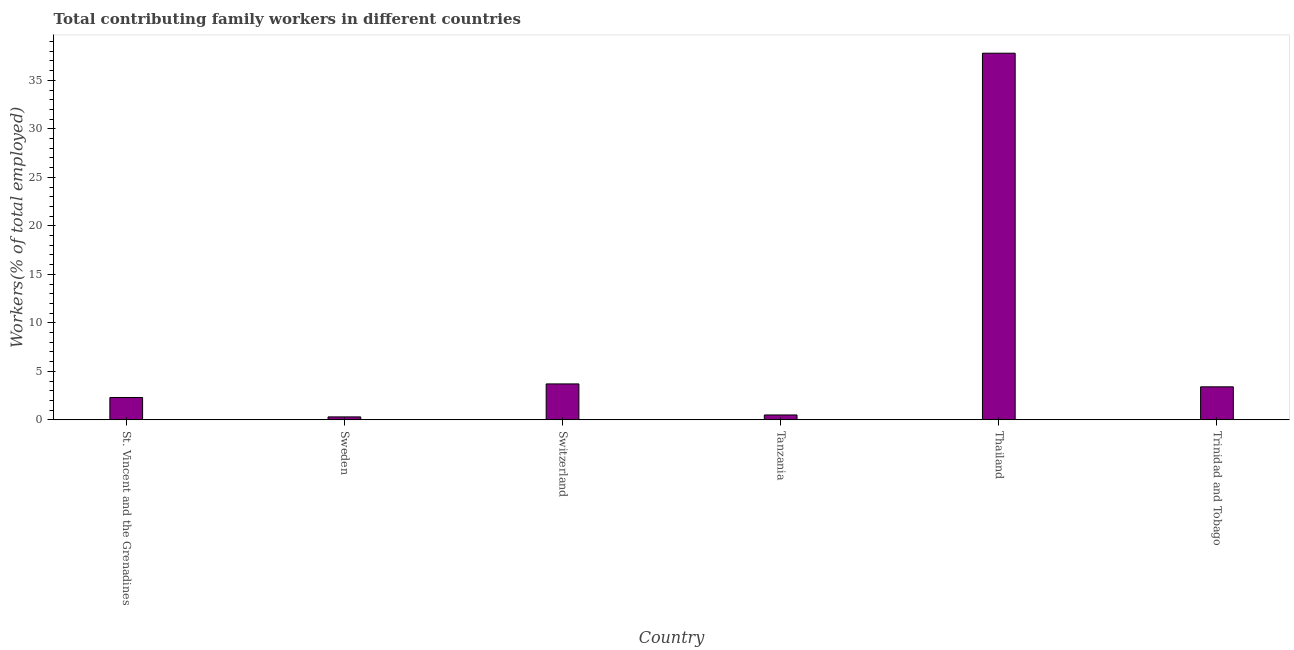Does the graph contain any zero values?
Provide a succinct answer. No. What is the title of the graph?
Give a very brief answer. Total contributing family workers in different countries. What is the label or title of the X-axis?
Make the answer very short. Country. What is the label or title of the Y-axis?
Provide a succinct answer. Workers(% of total employed). What is the contributing family workers in Trinidad and Tobago?
Provide a succinct answer. 3.4. Across all countries, what is the maximum contributing family workers?
Offer a very short reply. 37.8. Across all countries, what is the minimum contributing family workers?
Offer a terse response. 0.3. In which country was the contributing family workers maximum?
Offer a very short reply. Thailand. What is the sum of the contributing family workers?
Make the answer very short. 48. What is the difference between the contributing family workers in Sweden and Tanzania?
Make the answer very short. -0.2. What is the average contributing family workers per country?
Make the answer very short. 8. What is the median contributing family workers?
Make the answer very short. 2.85. What is the ratio of the contributing family workers in Sweden to that in Thailand?
Your answer should be compact. 0.01. Is the contributing family workers in St. Vincent and the Grenadines less than that in Trinidad and Tobago?
Your answer should be very brief. Yes. What is the difference between the highest and the second highest contributing family workers?
Your answer should be very brief. 34.1. What is the difference between the highest and the lowest contributing family workers?
Make the answer very short. 37.5. Are all the bars in the graph horizontal?
Provide a succinct answer. No. What is the difference between two consecutive major ticks on the Y-axis?
Your answer should be very brief. 5. What is the Workers(% of total employed) of St. Vincent and the Grenadines?
Provide a succinct answer. 2.3. What is the Workers(% of total employed) in Sweden?
Provide a succinct answer. 0.3. What is the Workers(% of total employed) in Switzerland?
Provide a short and direct response. 3.7. What is the Workers(% of total employed) in Tanzania?
Your answer should be compact. 0.5. What is the Workers(% of total employed) in Thailand?
Keep it short and to the point. 37.8. What is the Workers(% of total employed) of Trinidad and Tobago?
Your answer should be compact. 3.4. What is the difference between the Workers(% of total employed) in St. Vincent and the Grenadines and Sweden?
Ensure brevity in your answer.  2. What is the difference between the Workers(% of total employed) in St. Vincent and the Grenadines and Switzerland?
Make the answer very short. -1.4. What is the difference between the Workers(% of total employed) in St. Vincent and the Grenadines and Tanzania?
Your response must be concise. 1.8. What is the difference between the Workers(% of total employed) in St. Vincent and the Grenadines and Thailand?
Offer a very short reply. -35.5. What is the difference between the Workers(% of total employed) in St. Vincent and the Grenadines and Trinidad and Tobago?
Your answer should be very brief. -1.1. What is the difference between the Workers(% of total employed) in Sweden and Switzerland?
Keep it short and to the point. -3.4. What is the difference between the Workers(% of total employed) in Sweden and Tanzania?
Give a very brief answer. -0.2. What is the difference between the Workers(% of total employed) in Sweden and Thailand?
Offer a terse response. -37.5. What is the difference between the Workers(% of total employed) in Sweden and Trinidad and Tobago?
Give a very brief answer. -3.1. What is the difference between the Workers(% of total employed) in Switzerland and Tanzania?
Your response must be concise. 3.2. What is the difference between the Workers(% of total employed) in Switzerland and Thailand?
Provide a short and direct response. -34.1. What is the difference between the Workers(% of total employed) in Switzerland and Trinidad and Tobago?
Ensure brevity in your answer.  0.3. What is the difference between the Workers(% of total employed) in Tanzania and Thailand?
Provide a succinct answer. -37.3. What is the difference between the Workers(% of total employed) in Thailand and Trinidad and Tobago?
Your answer should be compact. 34.4. What is the ratio of the Workers(% of total employed) in St. Vincent and the Grenadines to that in Sweden?
Give a very brief answer. 7.67. What is the ratio of the Workers(% of total employed) in St. Vincent and the Grenadines to that in Switzerland?
Ensure brevity in your answer.  0.62. What is the ratio of the Workers(% of total employed) in St. Vincent and the Grenadines to that in Tanzania?
Keep it short and to the point. 4.6. What is the ratio of the Workers(% of total employed) in St. Vincent and the Grenadines to that in Thailand?
Your answer should be compact. 0.06. What is the ratio of the Workers(% of total employed) in St. Vincent and the Grenadines to that in Trinidad and Tobago?
Your answer should be very brief. 0.68. What is the ratio of the Workers(% of total employed) in Sweden to that in Switzerland?
Offer a very short reply. 0.08. What is the ratio of the Workers(% of total employed) in Sweden to that in Tanzania?
Ensure brevity in your answer.  0.6. What is the ratio of the Workers(% of total employed) in Sweden to that in Thailand?
Provide a short and direct response. 0.01. What is the ratio of the Workers(% of total employed) in Sweden to that in Trinidad and Tobago?
Your response must be concise. 0.09. What is the ratio of the Workers(% of total employed) in Switzerland to that in Thailand?
Your answer should be compact. 0.1. What is the ratio of the Workers(% of total employed) in Switzerland to that in Trinidad and Tobago?
Your answer should be very brief. 1.09. What is the ratio of the Workers(% of total employed) in Tanzania to that in Thailand?
Make the answer very short. 0.01. What is the ratio of the Workers(% of total employed) in Tanzania to that in Trinidad and Tobago?
Provide a short and direct response. 0.15. What is the ratio of the Workers(% of total employed) in Thailand to that in Trinidad and Tobago?
Ensure brevity in your answer.  11.12. 